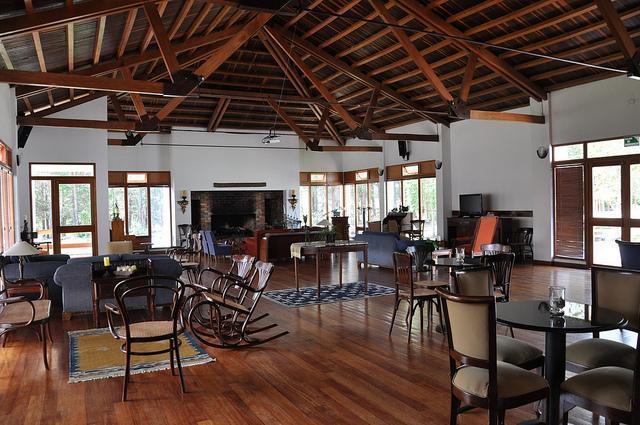How many people are in the room?
Give a very brief answer. 0. How many chairs are in the photo?
Give a very brief answer. 8. 